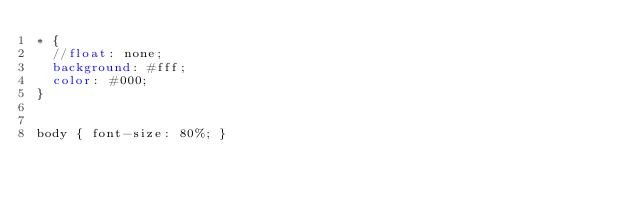Convert code to text. <code><loc_0><loc_0><loc_500><loc_500><_CSS_>* {
  //float: none;       
  background: #fff;  
  color: #000;
}


body { font-size: 80%; }</code> 